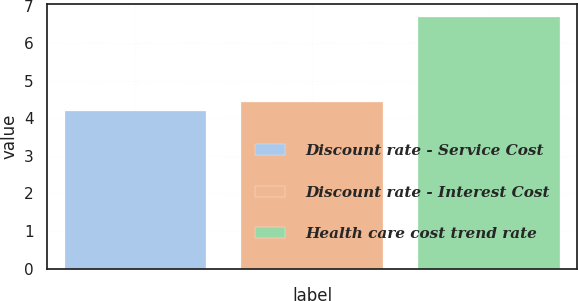Convert chart to OTSL. <chart><loc_0><loc_0><loc_500><loc_500><bar_chart><fcel>Discount rate - Service Cost<fcel>Discount rate - Interest Cost<fcel>Health care cost trend rate<nl><fcel>4.2<fcel>4.45<fcel>6.7<nl></chart> 